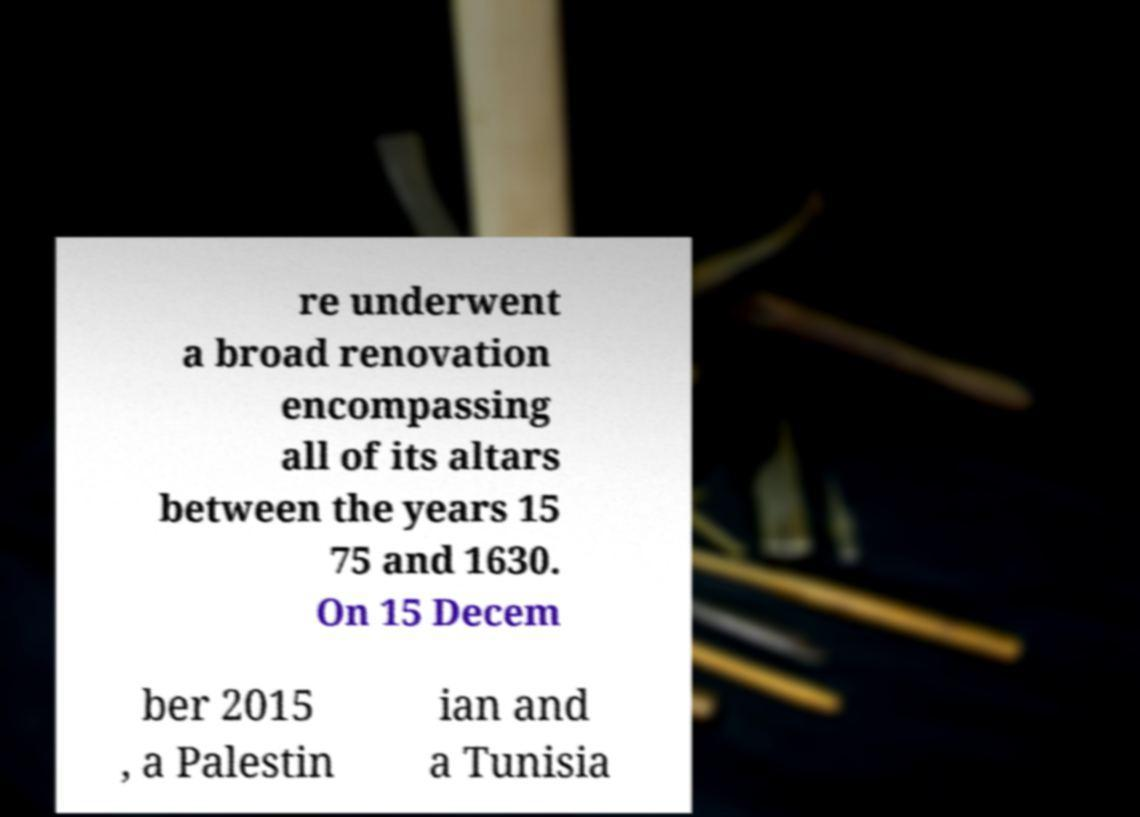For documentation purposes, I need the text within this image transcribed. Could you provide that? re underwent a broad renovation encompassing all of its altars between the years 15 75 and 1630. On 15 Decem ber 2015 , a Palestin ian and a Tunisia 